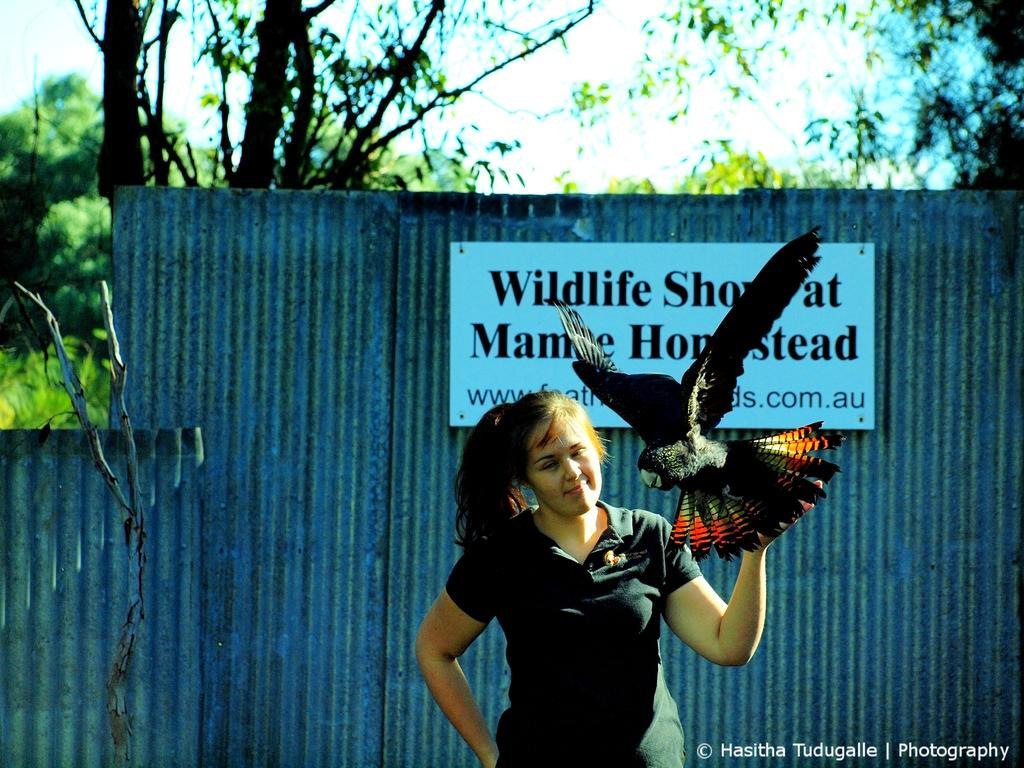Could you give a brief overview of what you see in this image? In this image at the bottom there is a woman, holding a bird, behind her there is a fence, on which there is a board attached, on which there is a text, behind the fence there are trees, the sky visible. 